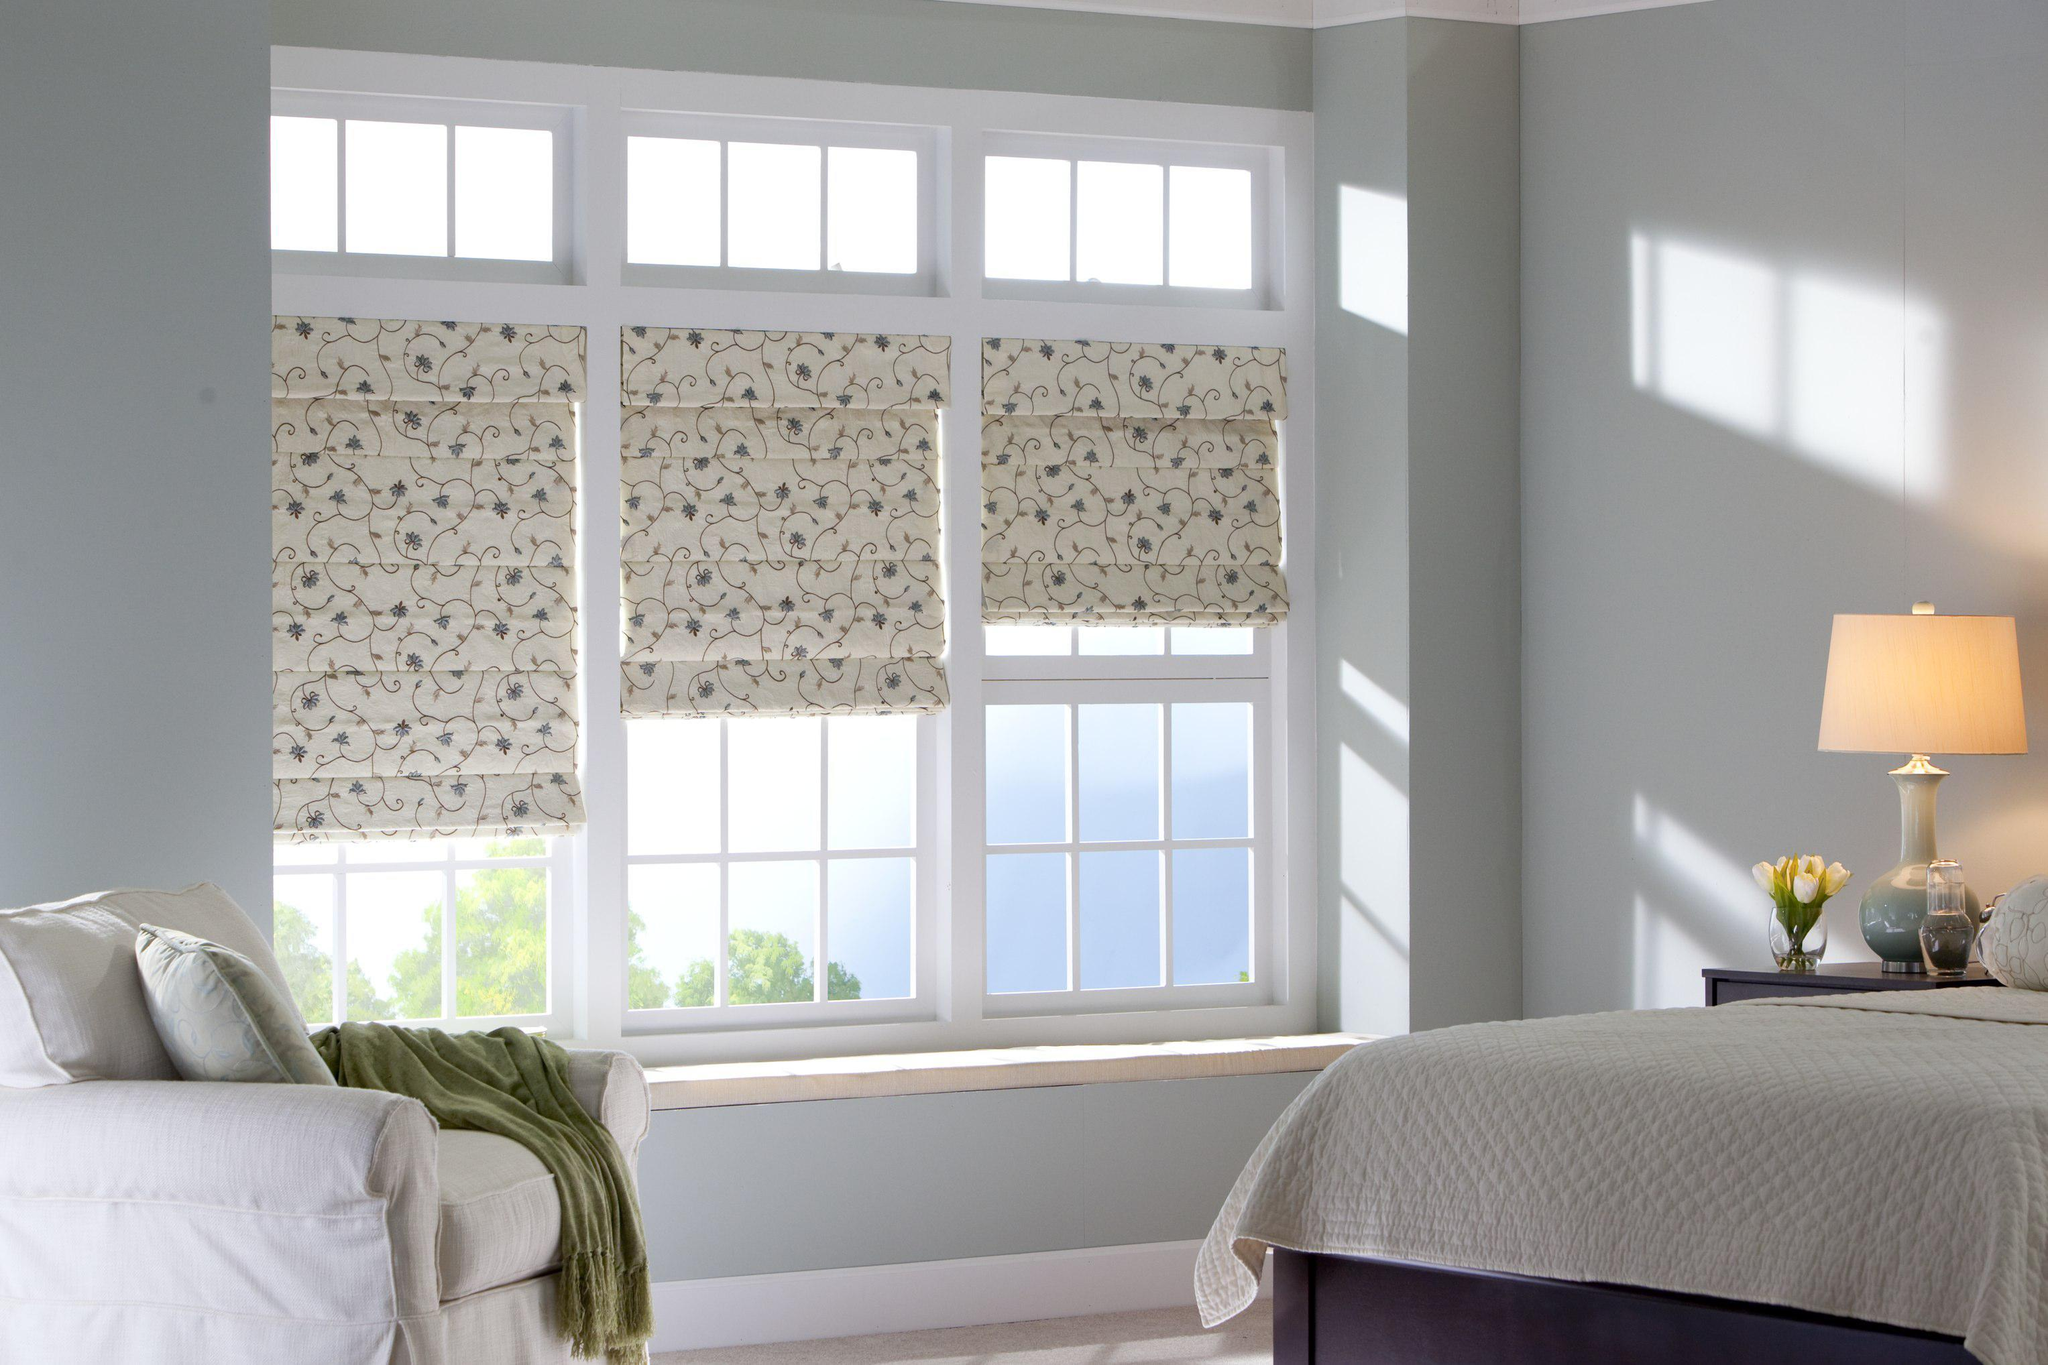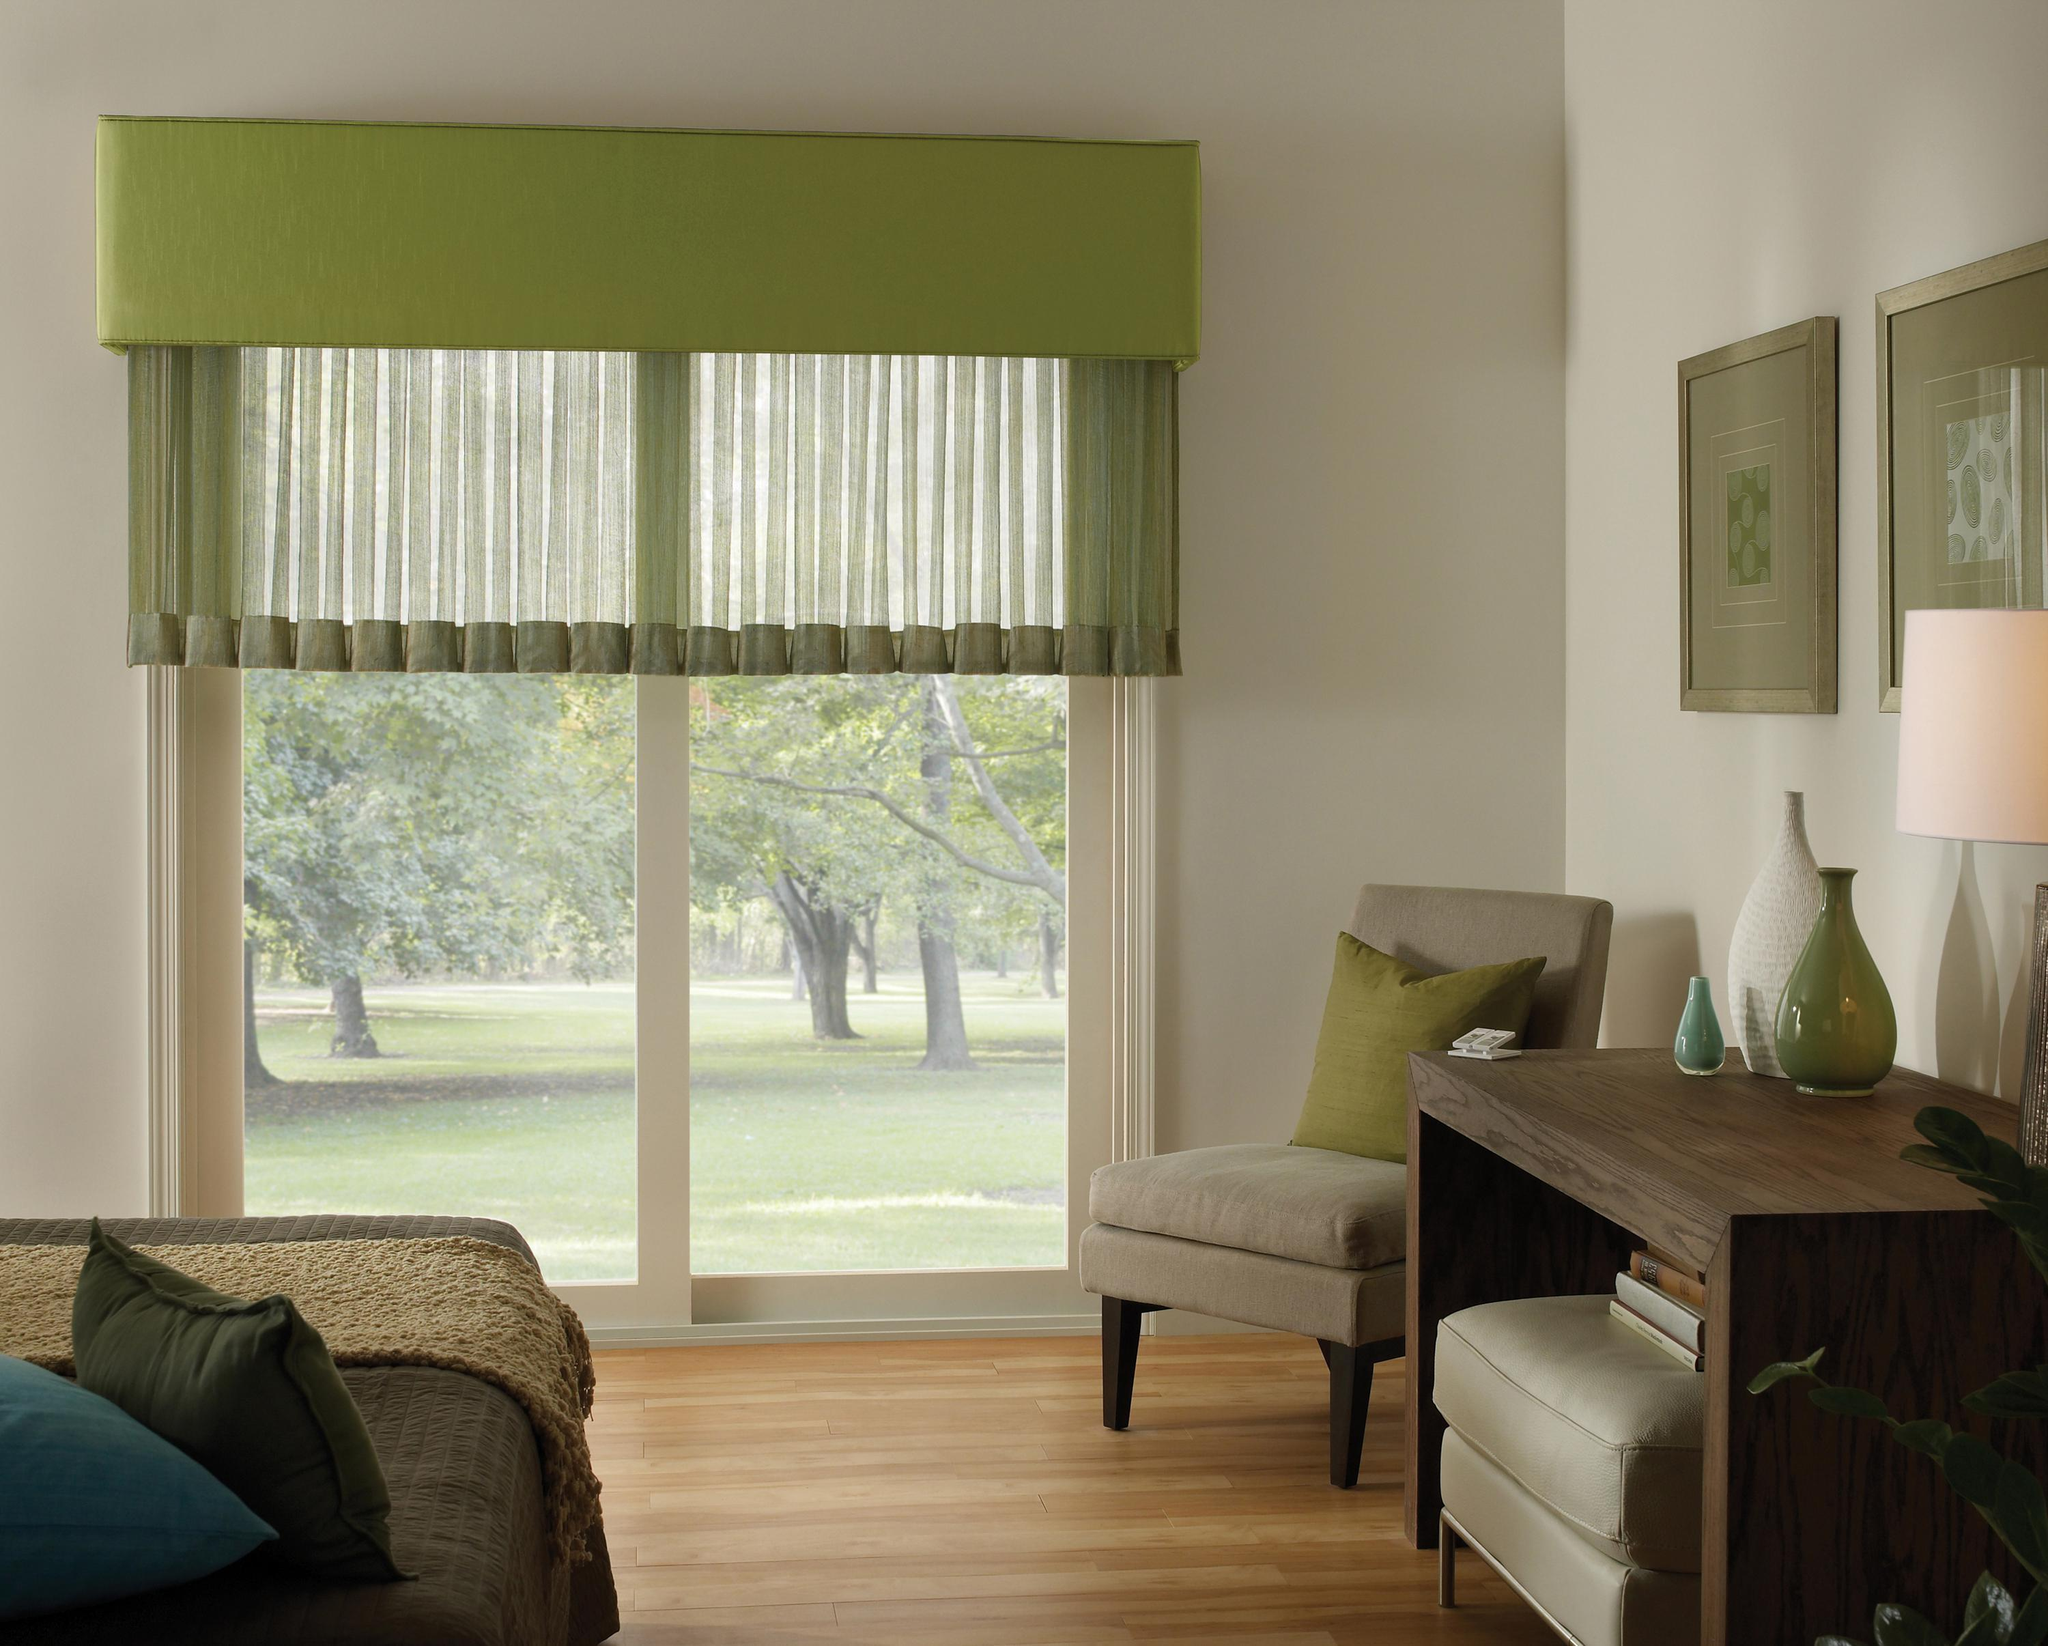The first image is the image on the left, the second image is the image on the right. Assess this claim about the two images: "There are exactly six window shades.". Correct or not? Answer yes or no. No. The first image is the image on the left, the second image is the image on the right. Examine the images to the left and right. Is the description "There are a total of six blinds." accurate? Answer yes or no. No. 